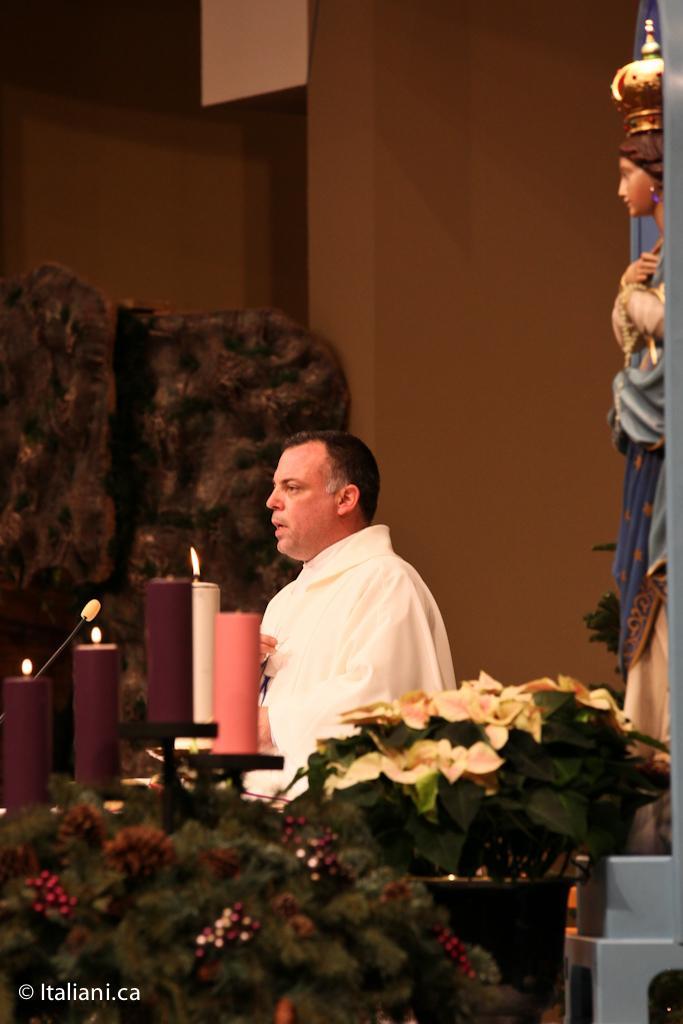Could you give a brief overview of what you see in this image? In the foreground of this image, there are few potted plants. On the right, there is a sculpture. In the background, there is a man standing in front of a mic and there are candles, a wall and an unclear object. 